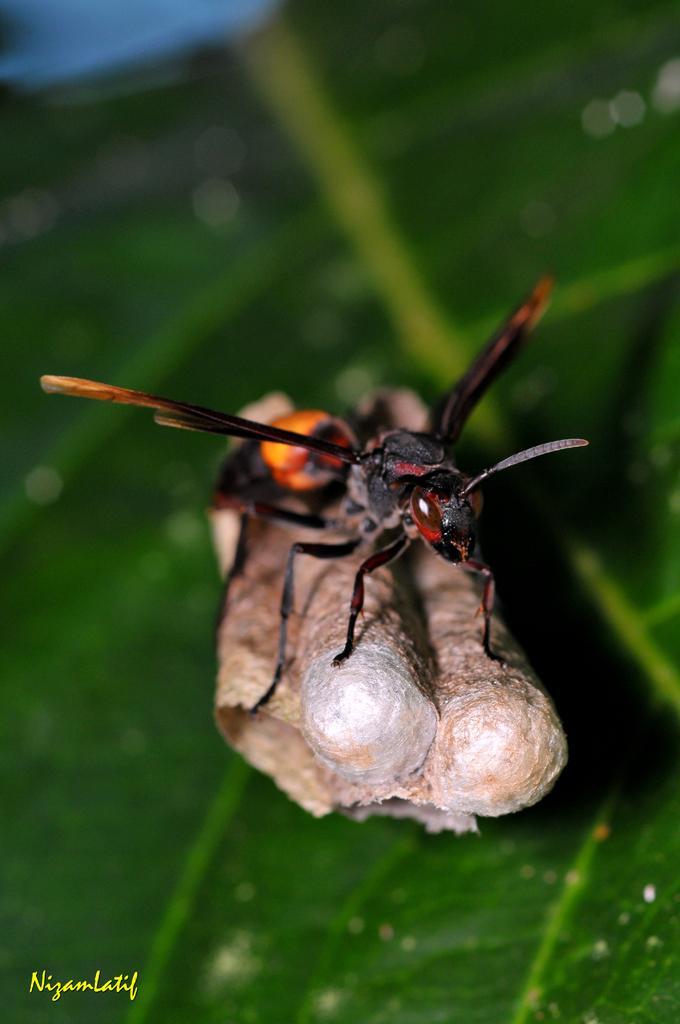Please provide a concise description of this image. In this picture there is an insect standing on an object and there is green leaf below it and there is something written in the left bottom corner. 